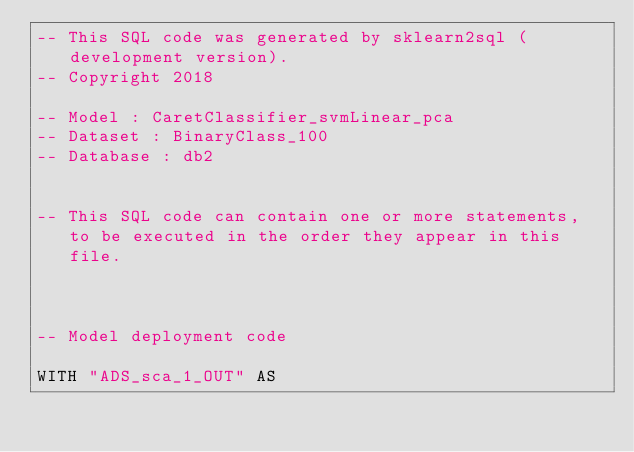Convert code to text. <code><loc_0><loc_0><loc_500><loc_500><_SQL_>-- This SQL code was generated by sklearn2sql (development version).
-- Copyright 2018

-- Model : CaretClassifier_svmLinear_pca
-- Dataset : BinaryClass_100
-- Database : db2


-- This SQL code can contain one or more statements, to be executed in the order they appear in this file.



-- Model deployment code

WITH "ADS_sca_1_OUT" AS </code> 